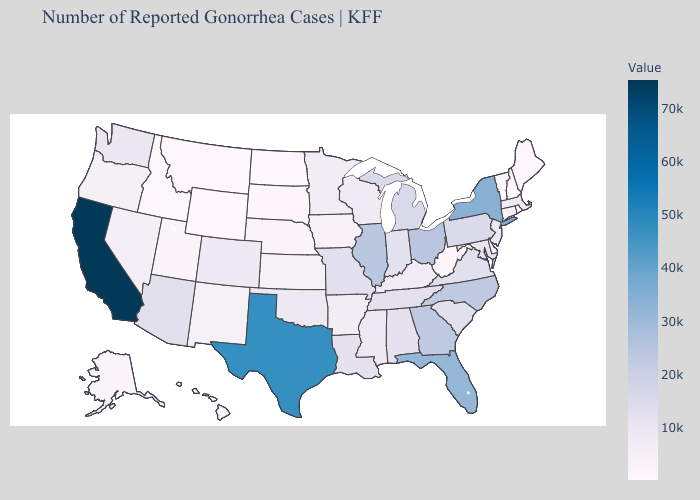Among the states that border New Mexico , does Arizona have the lowest value?
Concise answer only. No. Among the states that border Arizona , does Colorado have the lowest value?
Keep it brief. No. Which states have the lowest value in the USA?
Quick response, please. Vermont. Among the states that border California , does Arizona have the lowest value?
Quick response, please. No. 